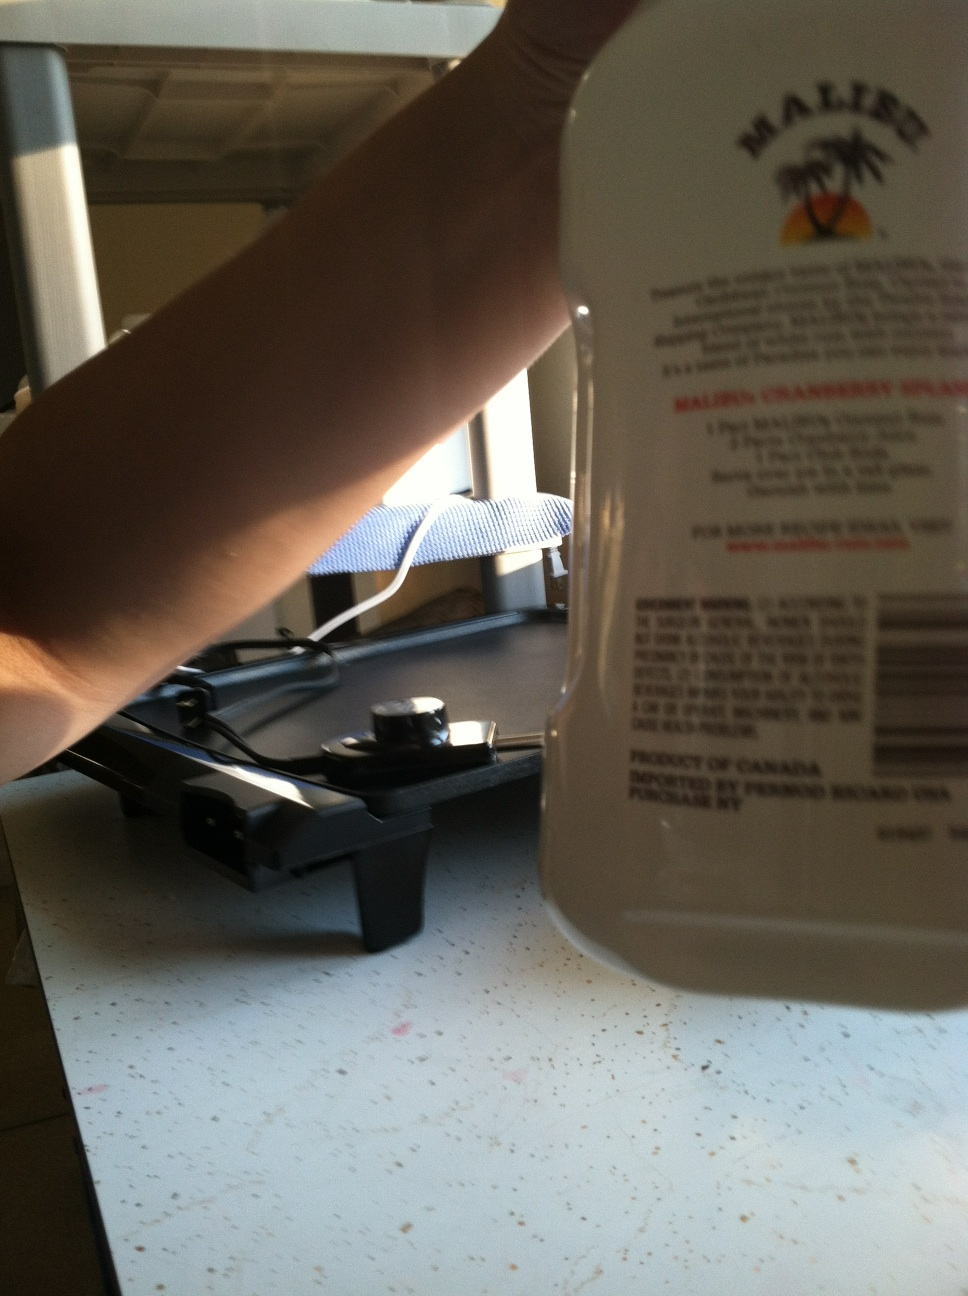Can you describe the location or setting where this bottle is placed? The bottle is placed on a surface that appears to be in an indoor setting, possibly a desk or a table, with other items and equipment around that might suggest a home or small office environment. 